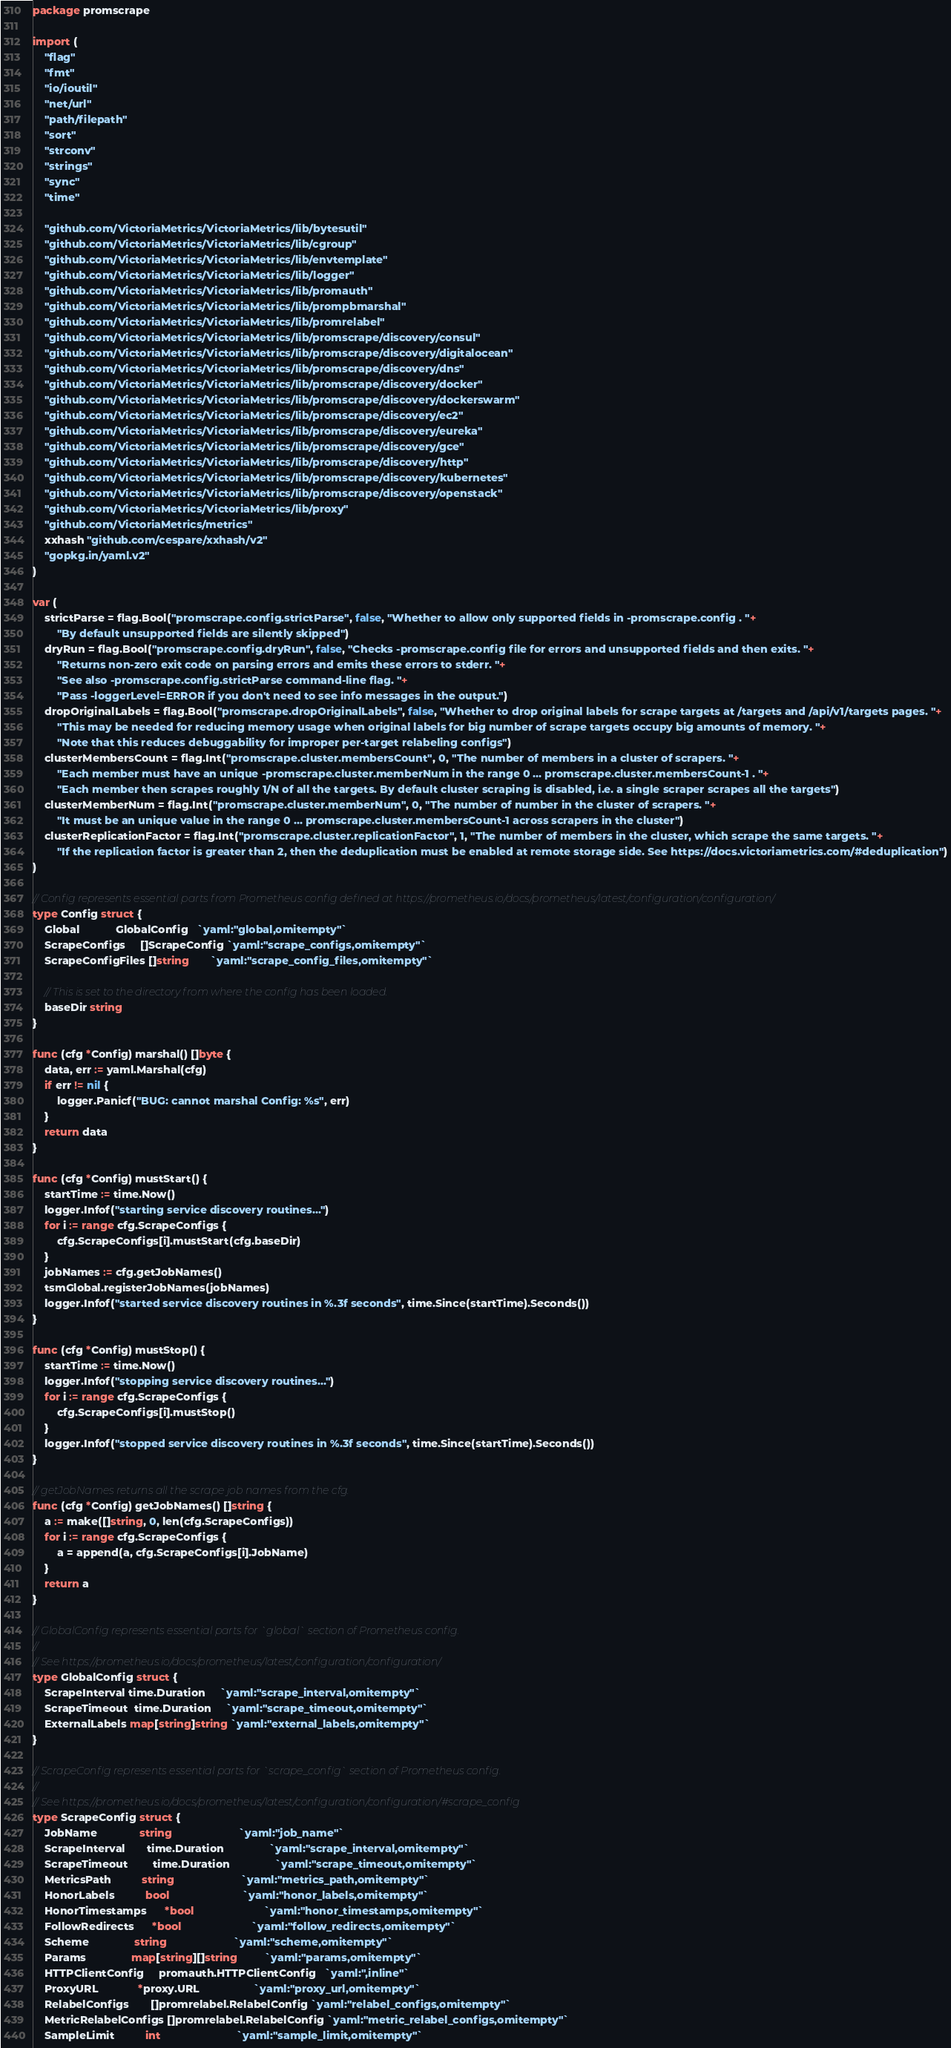Convert code to text. <code><loc_0><loc_0><loc_500><loc_500><_Go_>package promscrape

import (
	"flag"
	"fmt"
	"io/ioutil"
	"net/url"
	"path/filepath"
	"sort"
	"strconv"
	"strings"
	"sync"
	"time"

	"github.com/VictoriaMetrics/VictoriaMetrics/lib/bytesutil"
	"github.com/VictoriaMetrics/VictoriaMetrics/lib/cgroup"
	"github.com/VictoriaMetrics/VictoriaMetrics/lib/envtemplate"
	"github.com/VictoriaMetrics/VictoriaMetrics/lib/logger"
	"github.com/VictoriaMetrics/VictoriaMetrics/lib/promauth"
	"github.com/VictoriaMetrics/VictoriaMetrics/lib/prompbmarshal"
	"github.com/VictoriaMetrics/VictoriaMetrics/lib/promrelabel"
	"github.com/VictoriaMetrics/VictoriaMetrics/lib/promscrape/discovery/consul"
	"github.com/VictoriaMetrics/VictoriaMetrics/lib/promscrape/discovery/digitalocean"
	"github.com/VictoriaMetrics/VictoriaMetrics/lib/promscrape/discovery/dns"
	"github.com/VictoriaMetrics/VictoriaMetrics/lib/promscrape/discovery/docker"
	"github.com/VictoriaMetrics/VictoriaMetrics/lib/promscrape/discovery/dockerswarm"
	"github.com/VictoriaMetrics/VictoriaMetrics/lib/promscrape/discovery/ec2"
	"github.com/VictoriaMetrics/VictoriaMetrics/lib/promscrape/discovery/eureka"
	"github.com/VictoriaMetrics/VictoriaMetrics/lib/promscrape/discovery/gce"
	"github.com/VictoriaMetrics/VictoriaMetrics/lib/promscrape/discovery/http"
	"github.com/VictoriaMetrics/VictoriaMetrics/lib/promscrape/discovery/kubernetes"
	"github.com/VictoriaMetrics/VictoriaMetrics/lib/promscrape/discovery/openstack"
	"github.com/VictoriaMetrics/VictoriaMetrics/lib/proxy"
	"github.com/VictoriaMetrics/metrics"
	xxhash "github.com/cespare/xxhash/v2"
	"gopkg.in/yaml.v2"
)

var (
	strictParse = flag.Bool("promscrape.config.strictParse", false, "Whether to allow only supported fields in -promscrape.config . "+
		"By default unsupported fields are silently skipped")
	dryRun = flag.Bool("promscrape.config.dryRun", false, "Checks -promscrape.config file for errors and unsupported fields and then exits. "+
		"Returns non-zero exit code on parsing errors and emits these errors to stderr. "+
		"See also -promscrape.config.strictParse command-line flag. "+
		"Pass -loggerLevel=ERROR if you don't need to see info messages in the output.")
	dropOriginalLabels = flag.Bool("promscrape.dropOriginalLabels", false, "Whether to drop original labels for scrape targets at /targets and /api/v1/targets pages. "+
		"This may be needed for reducing memory usage when original labels for big number of scrape targets occupy big amounts of memory. "+
		"Note that this reduces debuggability for improper per-target relabeling configs")
	clusterMembersCount = flag.Int("promscrape.cluster.membersCount", 0, "The number of members in a cluster of scrapers. "+
		"Each member must have an unique -promscrape.cluster.memberNum in the range 0 ... promscrape.cluster.membersCount-1 . "+
		"Each member then scrapes roughly 1/N of all the targets. By default cluster scraping is disabled, i.e. a single scraper scrapes all the targets")
	clusterMemberNum = flag.Int("promscrape.cluster.memberNum", 0, "The number of number in the cluster of scrapers. "+
		"It must be an unique value in the range 0 ... promscrape.cluster.membersCount-1 across scrapers in the cluster")
	clusterReplicationFactor = flag.Int("promscrape.cluster.replicationFactor", 1, "The number of members in the cluster, which scrape the same targets. "+
		"If the replication factor is greater than 2, then the deduplication must be enabled at remote storage side. See https://docs.victoriametrics.com/#deduplication")
)

// Config represents essential parts from Prometheus config defined at https://prometheus.io/docs/prometheus/latest/configuration/configuration/
type Config struct {
	Global            GlobalConfig   `yaml:"global,omitempty"`
	ScrapeConfigs     []ScrapeConfig `yaml:"scrape_configs,omitempty"`
	ScrapeConfigFiles []string       `yaml:"scrape_config_files,omitempty"`

	// This is set to the directory from where the config has been loaded.
	baseDir string
}

func (cfg *Config) marshal() []byte {
	data, err := yaml.Marshal(cfg)
	if err != nil {
		logger.Panicf("BUG: cannot marshal Config: %s", err)
	}
	return data
}

func (cfg *Config) mustStart() {
	startTime := time.Now()
	logger.Infof("starting service discovery routines...")
	for i := range cfg.ScrapeConfigs {
		cfg.ScrapeConfigs[i].mustStart(cfg.baseDir)
	}
	jobNames := cfg.getJobNames()
	tsmGlobal.registerJobNames(jobNames)
	logger.Infof("started service discovery routines in %.3f seconds", time.Since(startTime).Seconds())
}

func (cfg *Config) mustStop() {
	startTime := time.Now()
	logger.Infof("stopping service discovery routines...")
	for i := range cfg.ScrapeConfigs {
		cfg.ScrapeConfigs[i].mustStop()
	}
	logger.Infof("stopped service discovery routines in %.3f seconds", time.Since(startTime).Seconds())
}

// getJobNames returns all the scrape job names from the cfg.
func (cfg *Config) getJobNames() []string {
	a := make([]string, 0, len(cfg.ScrapeConfigs))
	for i := range cfg.ScrapeConfigs {
		a = append(a, cfg.ScrapeConfigs[i].JobName)
	}
	return a
}

// GlobalConfig represents essential parts for `global` section of Prometheus config.
//
// See https://prometheus.io/docs/prometheus/latest/configuration/configuration/
type GlobalConfig struct {
	ScrapeInterval time.Duration     `yaml:"scrape_interval,omitempty"`
	ScrapeTimeout  time.Duration     `yaml:"scrape_timeout,omitempty"`
	ExternalLabels map[string]string `yaml:"external_labels,omitempty"`
}

// ScrapeConfig represents essential parts for `scrape_config` section of Prometheus config.
//
// See https://prometheus.io/docs/prometheus/latest/configuration/configuration/#scrape_config
type ScrapeConfig struct {
	JobName              string                      `yaml:"job_name"`
	ScrapeInterval       time.Duration               `yaml:"scrape_interval,omitempty"`
	ScrapeTimeout        time.Duration               `yaml:"scrape_timeout,omitempty"`
	MetricsPath          string                      `yaml:"metrics_path,omitempty"`
	HonorLabels          bool                        `yaml:"honor_labels,omitempty"`
	HonorTimestamps      *bool                       `yaml:"honor_timestamps,omitempty"`
	FollowRedirects      *bool                       `yaml:"follow_redirects,omitempty"`
	Scheme               string                      `yaml:"scheme,omitempty"`
	Params               map[string][]string         `yaml:"params,omitempty"`
	HTTPClientConfig     promauth.HTTPClientConfig   `yaml:",inline"`
	ProxyURL             *proxy.URL                  `yaml:"proxy_url,omitempty"`
	RelabelConfigs       []promrelabel.RelabelConfig `yaml:"relabel_configs,omitempty"`
	MetricRelabelConfigs []promrelabel.RelabelConfig `yaml:"metric_relabel_configs,omitempty"`
	SampleLimit          int                         `yaml:"sample_limit,omitempty"`
</code> 